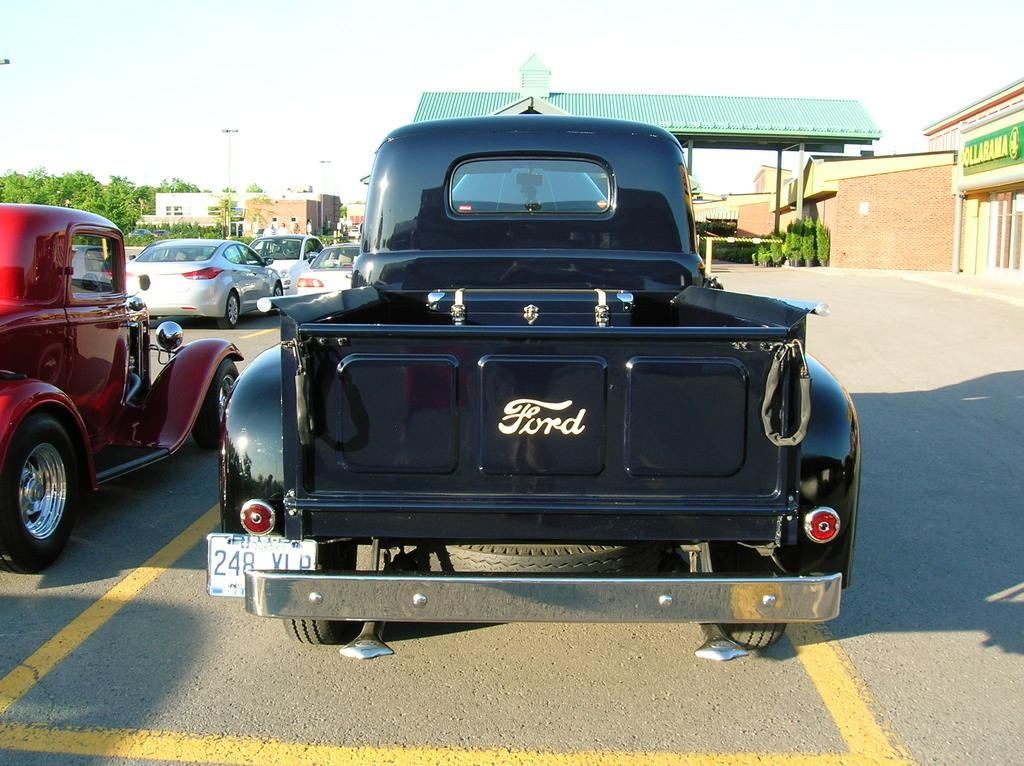What types of objects can be seen in the image? There are vehicles, houses, poles, trees, plants, and a shed visible in the image. What part of the natural environment is visible in the image? The ground and the sky are visible in the image. What is the purpose of the poles in the image? The purpose of the poles is not explicitly stated, but they may be used for supporting power lines or other infrastructure. Can you describe the text on the right side of the image? The text on the right side of the image is not legible, so it cannot be described in detail. How many matches are visible in the image? There are no matches present in the image. What is the aftermath of the house in the image? There is no indication of any aftermath in the image; the house appears to be intact. 